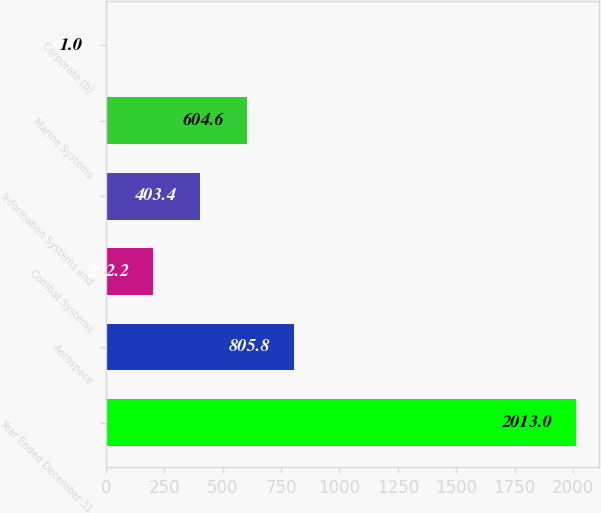Convert chart. <chart><loc_0><loc_0><loc_500><loc_500><bar_chart><fcel>Year Ended December 31<fcel>Aerospace<fcel>Combat Systems<fcel>Information Systems and<fcel>Marine Systems<fcel>Corporate (b)<nl><fcel>2013<fcel>805.8<fcel>202.2<fcel>403.4<fcel>604.6<fcel>1<nl></chart> 